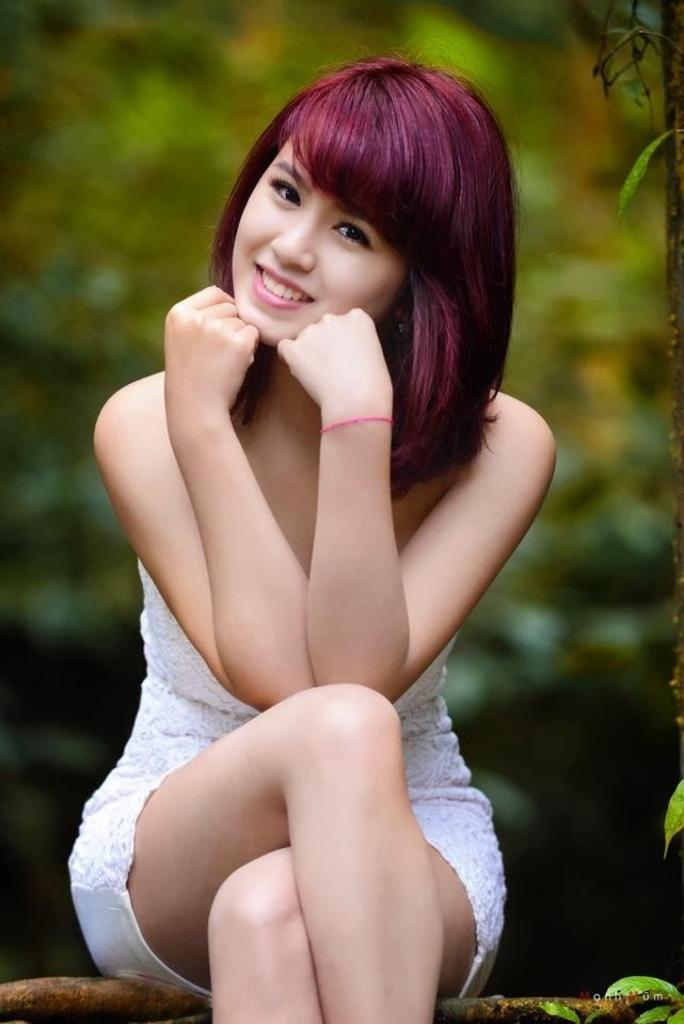In one or two sentences, can you explain what this image depicts? In this image there is a girl sitting. In the background there are trees. On the right side, there are leaves. 